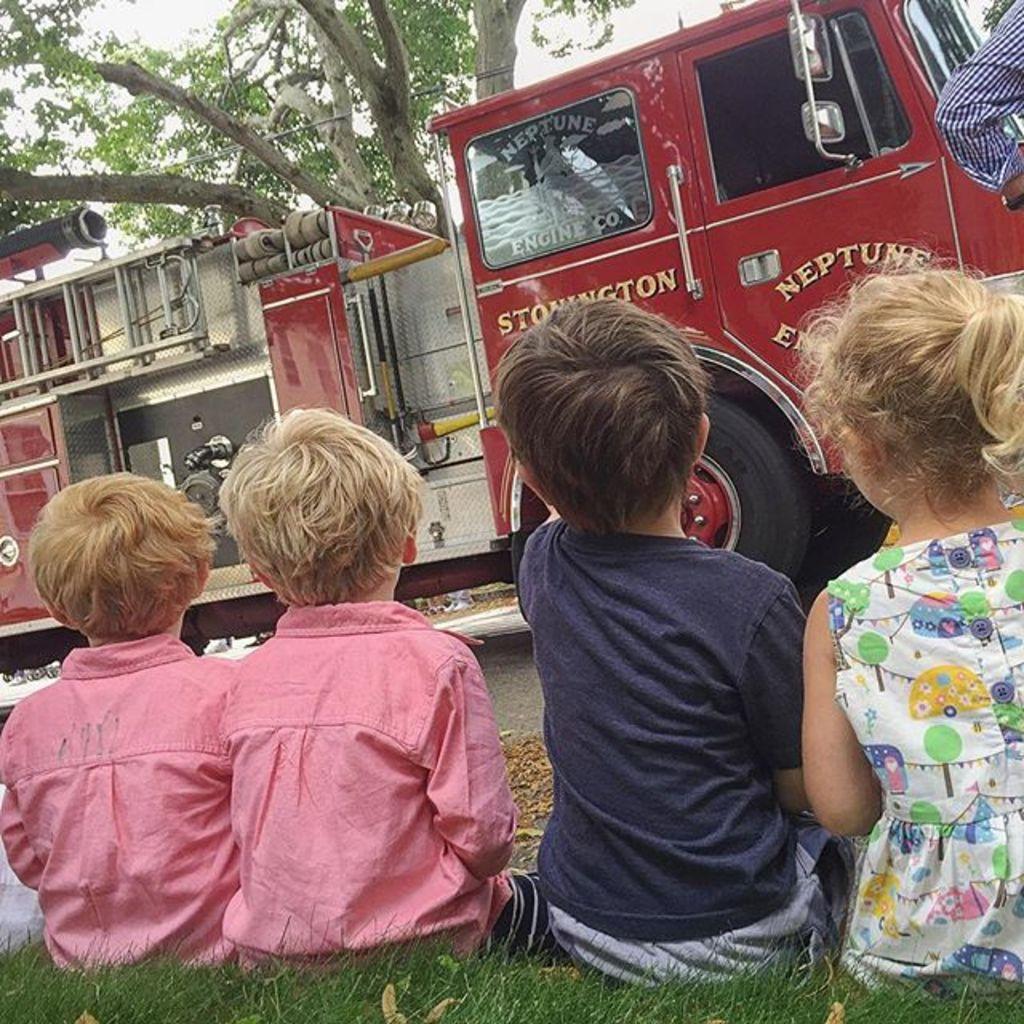Describe this image in one or two sentences. In this image I can see a vehicle and in front of the vehicle I can see there are children's sitting on grass and at the top I can see the sky and on the right side I can see a person hand 